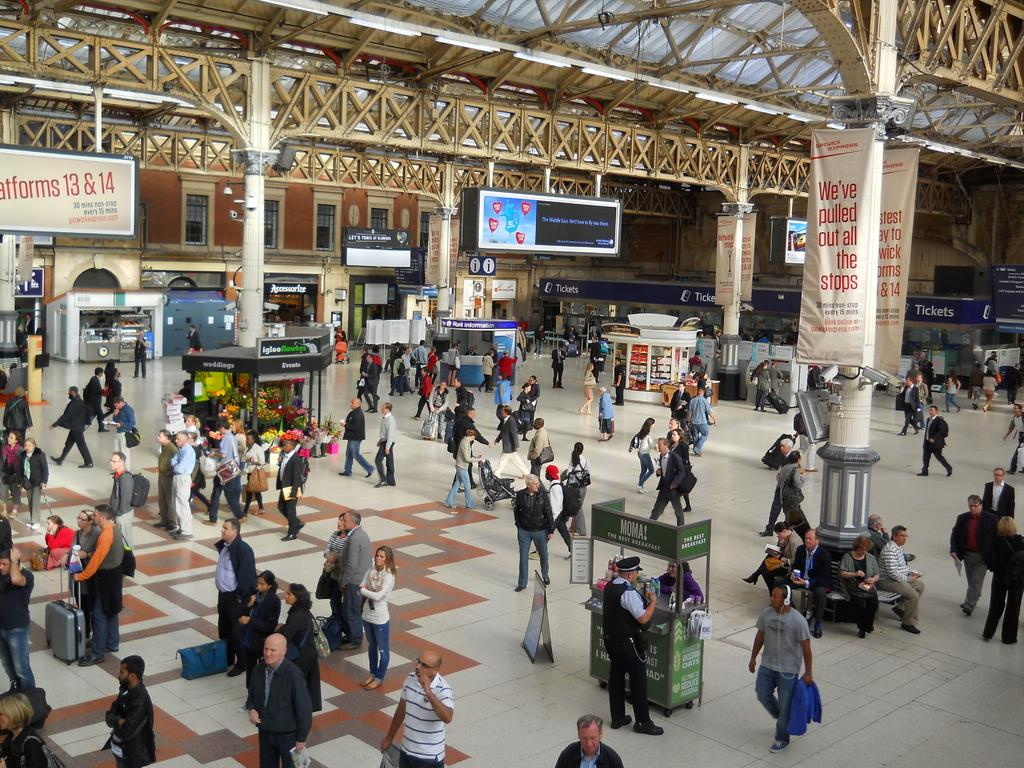Provide a one-sentence caption for the provided image. In a train station platform, a banner proclaims, "We've pulled out all the stops.". 